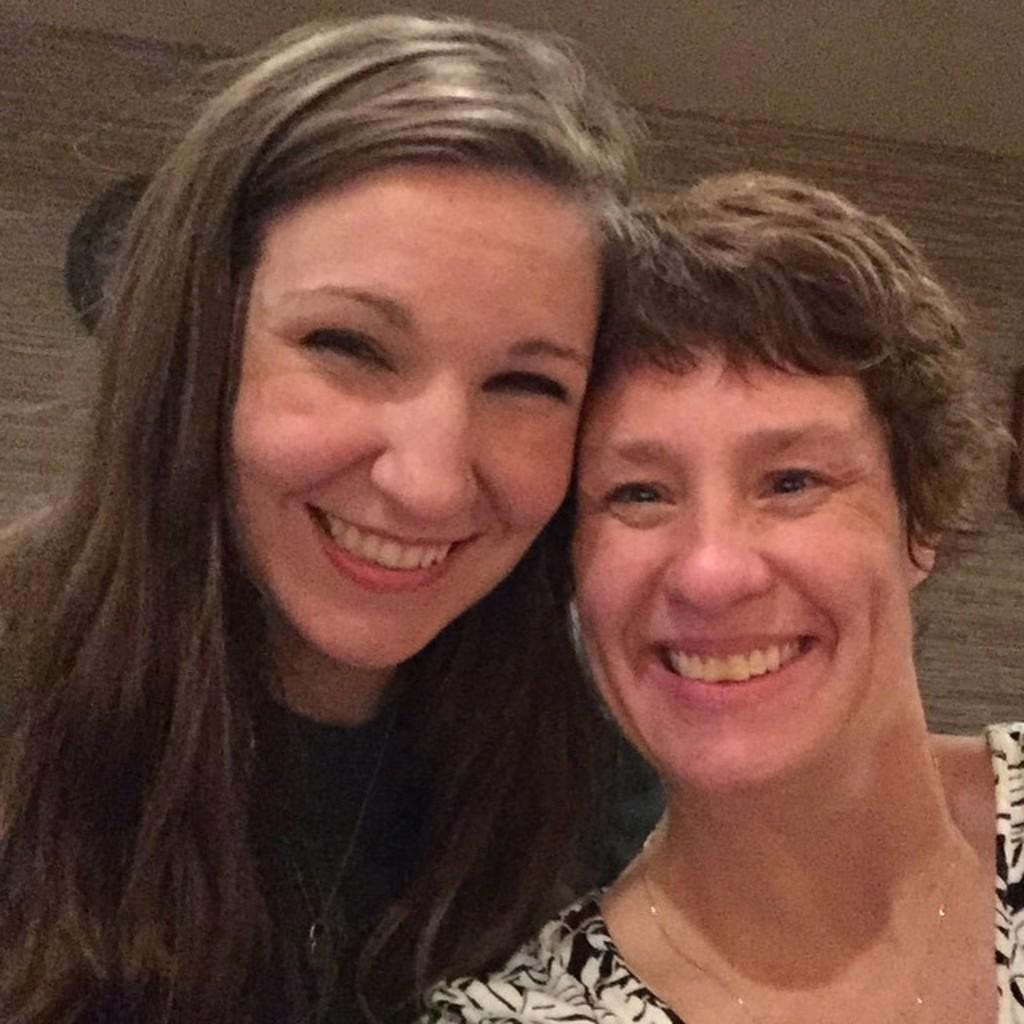How many women are present in the image? There are two women in the image. What expression do the women have in the image? The women are smiling in the image. What is visible in the background of the image? There is a wall in the background of the image. What type of ball can be seen in the image? There is no ball present in the image. What kind of art is being created by the women in the image? There is no art creation activity depicted in the image; the women are simply smiling. 